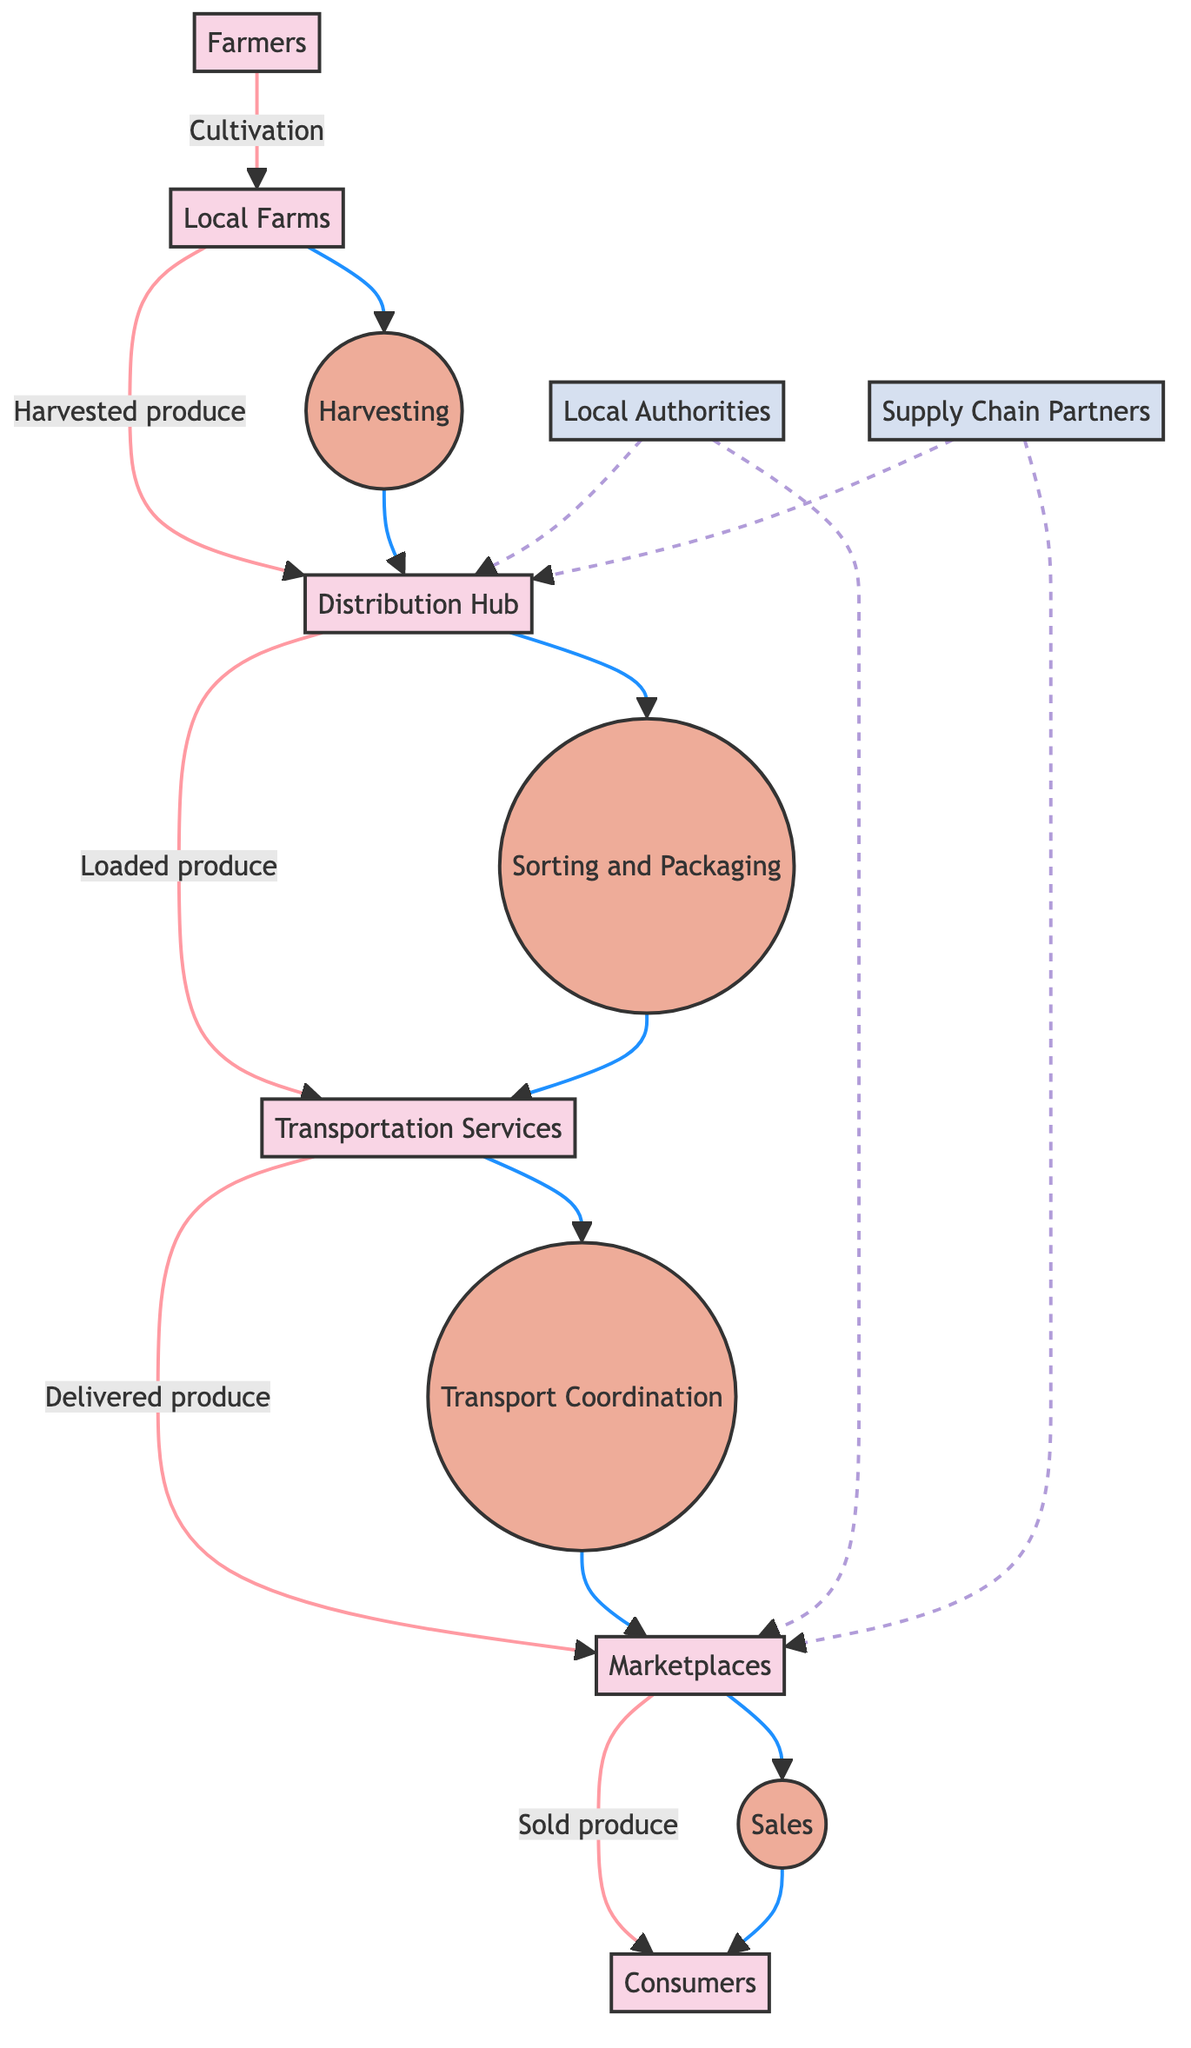What are the entities involved in this agricultural distribution process? The diagram identifies six entities: Farmers, Local Farms, Distribution Hub, Transportation Services, Marketplaces, and Consumers. These entities represent the participants in the agricultural produce distribution process.
Answer: Farmers, Local Farms, Distribution Hub, Transportation Services, Marketplaces, Consumers What is the flow of harvested produce from Local Farms? The harvested produce is collected from Local Farms and transported to the Distribution Hub. The diagram shows the flow starting from Local Farms to the Distribution Hub, indicating that this is the first step after harvesting.
Answer: Distribution Hub How many processes are included in the diagram? There are four processes shown in the diagram: Harvesting, Sorting and Packaging, Transport Coordination, and Sales. The processes indicate the main activities taking place in the distribution chain.
Answer: Four What do the Local Authorities oversee in relation to the Distribution Hub? Local Authorities are responsible for food safety and quality regulations at both the Distribution Hub and Marketplaces. The dashed lines indicate an oversight connection to both entities in the diagram.
Answer: Food safety and quality regulations What is the sequence of actions that take place after the produce leaves the Distribution Hub? After leaving the Distribution Hub, the produce goes through Sorting and Packaging, then is loaded onto Transportation Services, coordinated for delivery, and finally transported to Marketplaces. This sequence includes four steps from the Distribution Hub onwards.
Answer: Sorting and Packaging, Transportation Services, Marketplaces How are the Transportation Services utilized in the distribution process? Transportation Services are used for delivering produce to the Marketplaces after they have been loaded with produce from the Distribution Hub. The arrows in the diagram illustrate this direct flow from Transportation Services to Marketplaces.
Answer: Delivery to Marketplaces Which external entities are involved in the agricultural produce distribution? The external entities involved are Local Authorities and Supply Chain Partners. These entities provide oversight and additional support to the distribution process as shown in the diagram.
Answer: Local Authorities, Supply Chain Partners What action follows the Sorting and Packaging of the produce? After the produce is sorted and packaged, it is loaded into Transportation Services for delivery to Marketplaces. This shows that Sorting and Packaging is immediately followed by a loading action in the diagram.
Answer: Loading into Transportation Services What happens to the produce once it reaches the Marketplaces? Once the produce reaches the Marketplaces, it is sold to Consumers. The diagram indicates that this is the final action in the distribution flow before selling.
Answer: Sold to Consumers 